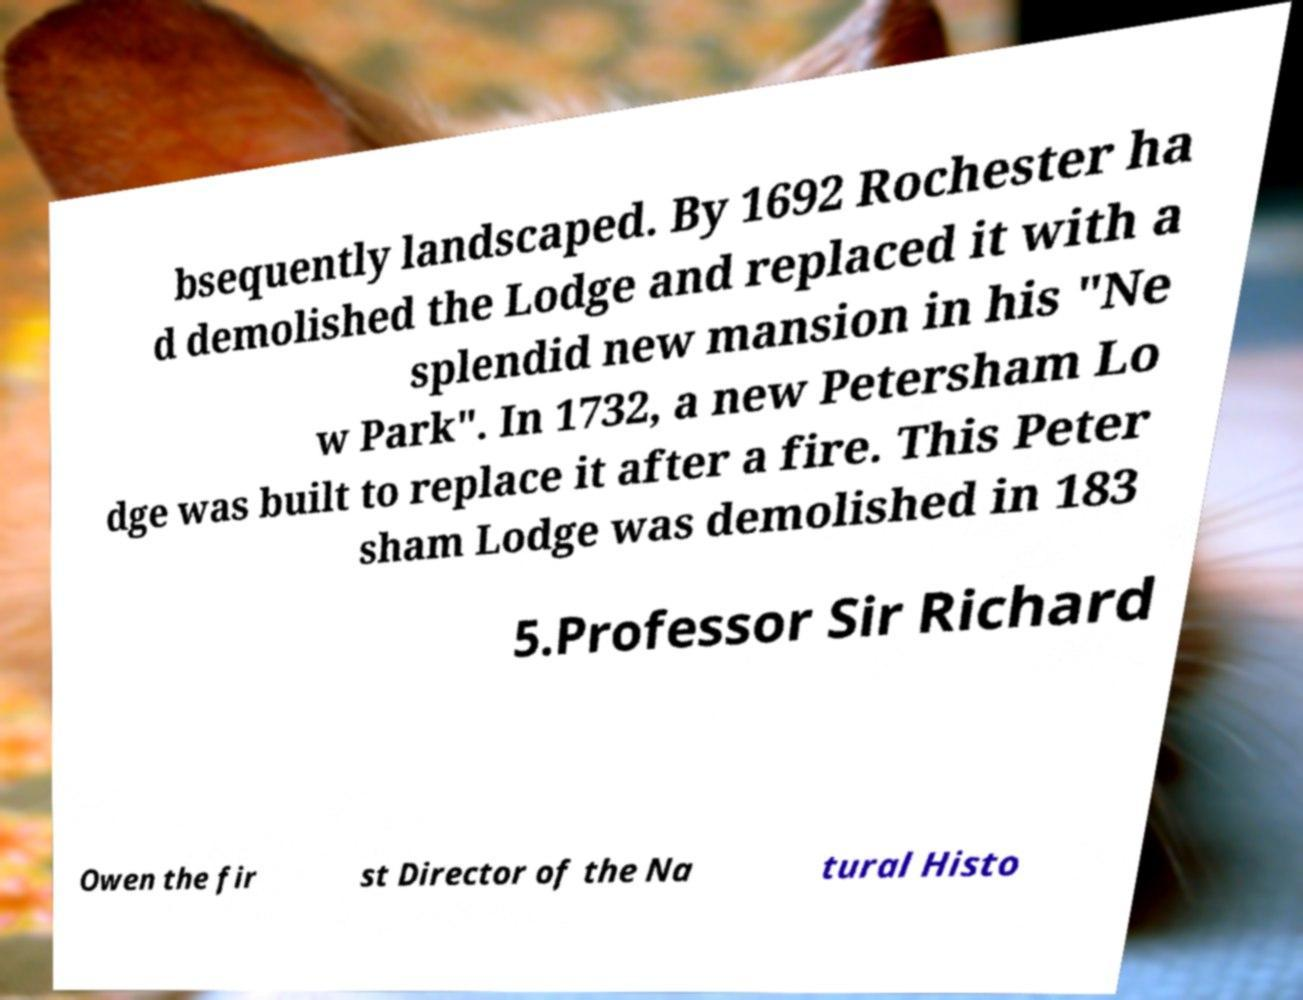There's text embedded in this image that I need extracted. Can you transcribe it verbatim? bsequently landscaped. By 1692 Rochester ha d demolished the Lodge and replaced it with a splendid new mansion in his "Ne w Park". In 1732, a new Petersham Lo dge was built to replace it after a fire. This Peter sham Lodge was demolished in 183 5.Professor Sir Richard Owen the fir st Director of the Na tural Histo 